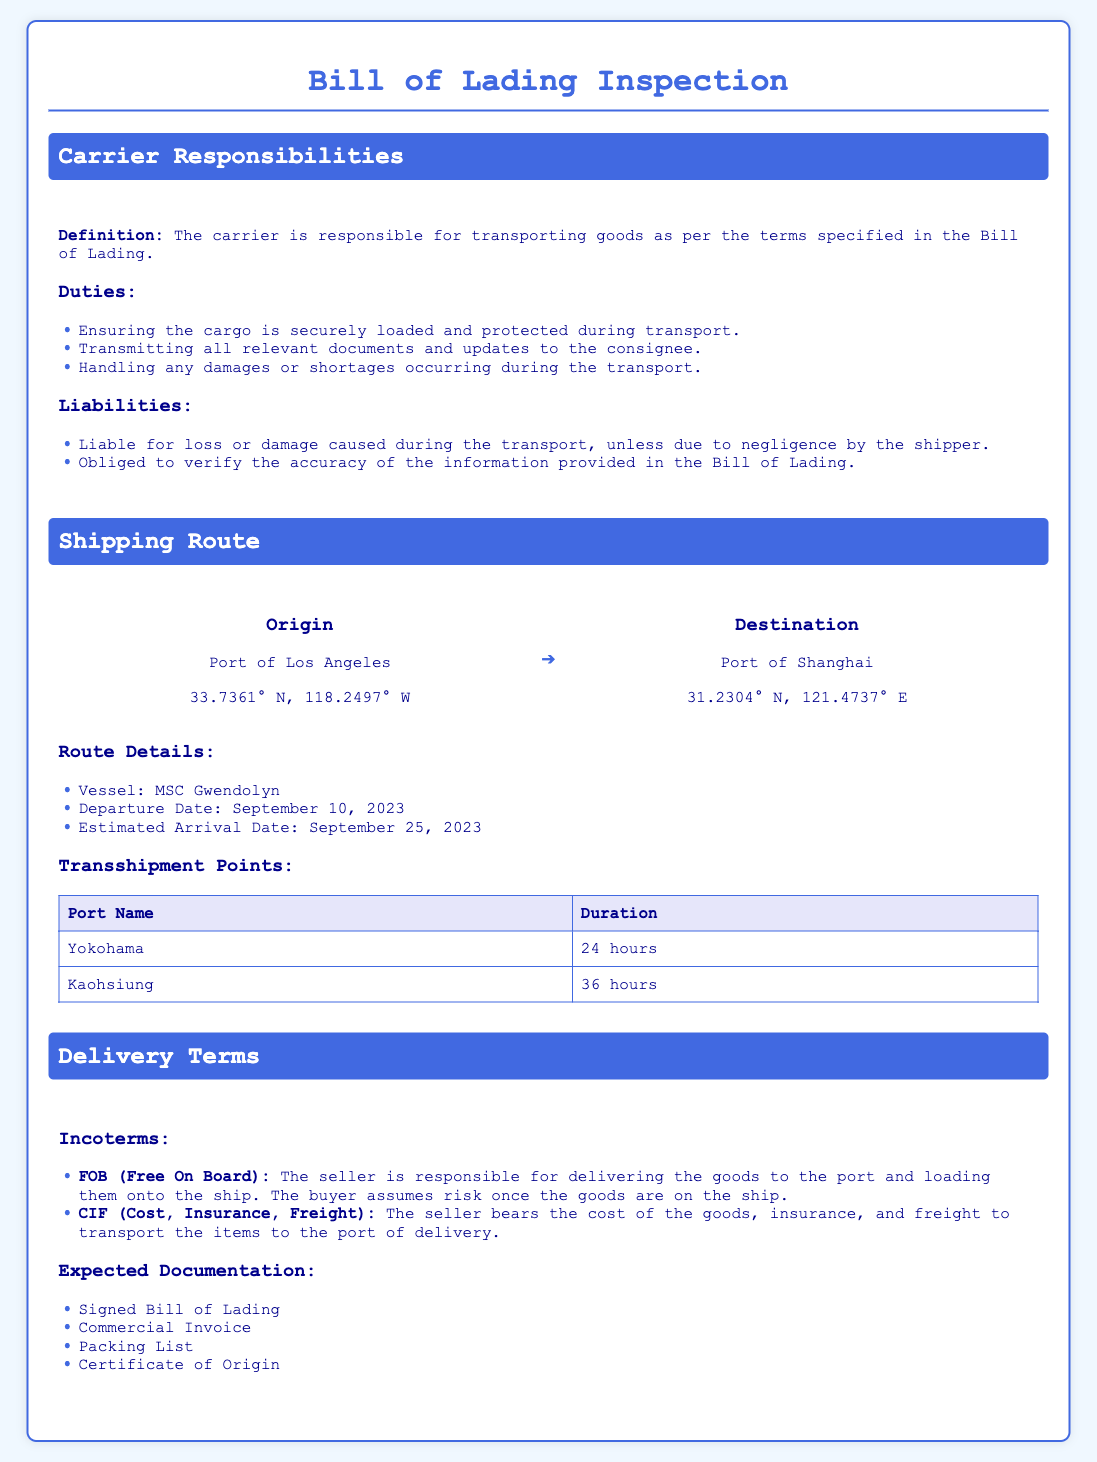What is the carrier's primary responsibility? The carrier is responsible for transporting goods as per the terms specified in the Bill of Lading.
Answer: Transporting goods What is the estimated arrival date? The estimated arrival date is specified in the shipping route details.
Answer: September 25, 2023 What are the transshipment points listed? The table under transshipment points provides the names of the ports.
Answer: Yokohama, Kaohsiung What does FOB stand for? FOB is an acronym used in the delivery terms to indicate the seller's responsibility.
Answer: Free On Board How long is the stay at Yokohama? The duration at Yokohama is indicated in the transshipment points table.
Answer: 24 hours Who is responsible for the cargo once it's loaded on the ship under FOB terms? The question clarifies liability transfer under the Incoterms used.
Answer: The buyer What vessel is mentioned in the shipping route? The vessel name is provided in the shipping route details.
Answer: MSC Gwendolyn What is the port of origin? The document specifies the starting point of the shipping route.
Answer: Port of Los Angeles What type of document is expected to be signed at delivery? This question refers to the expected documentation listed under delivery terms.
Answer: Signed Bill of Lading 